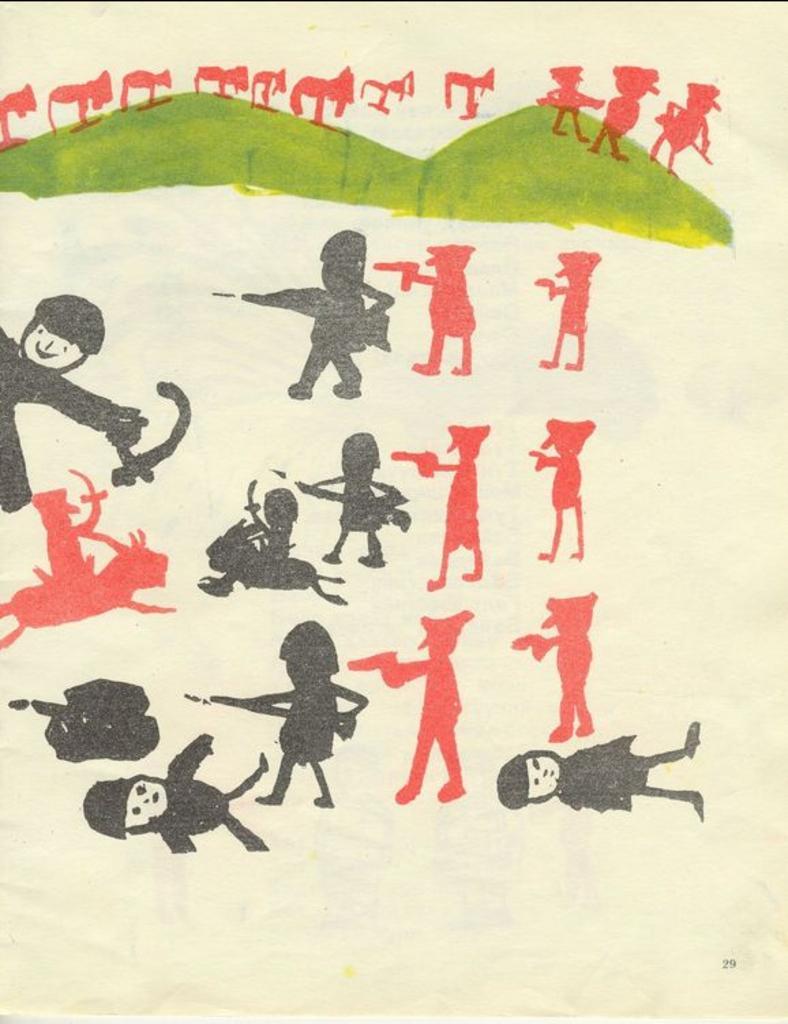Describe this image in one or two sentences. This is a drawing in this image there are some toys and mountains. 